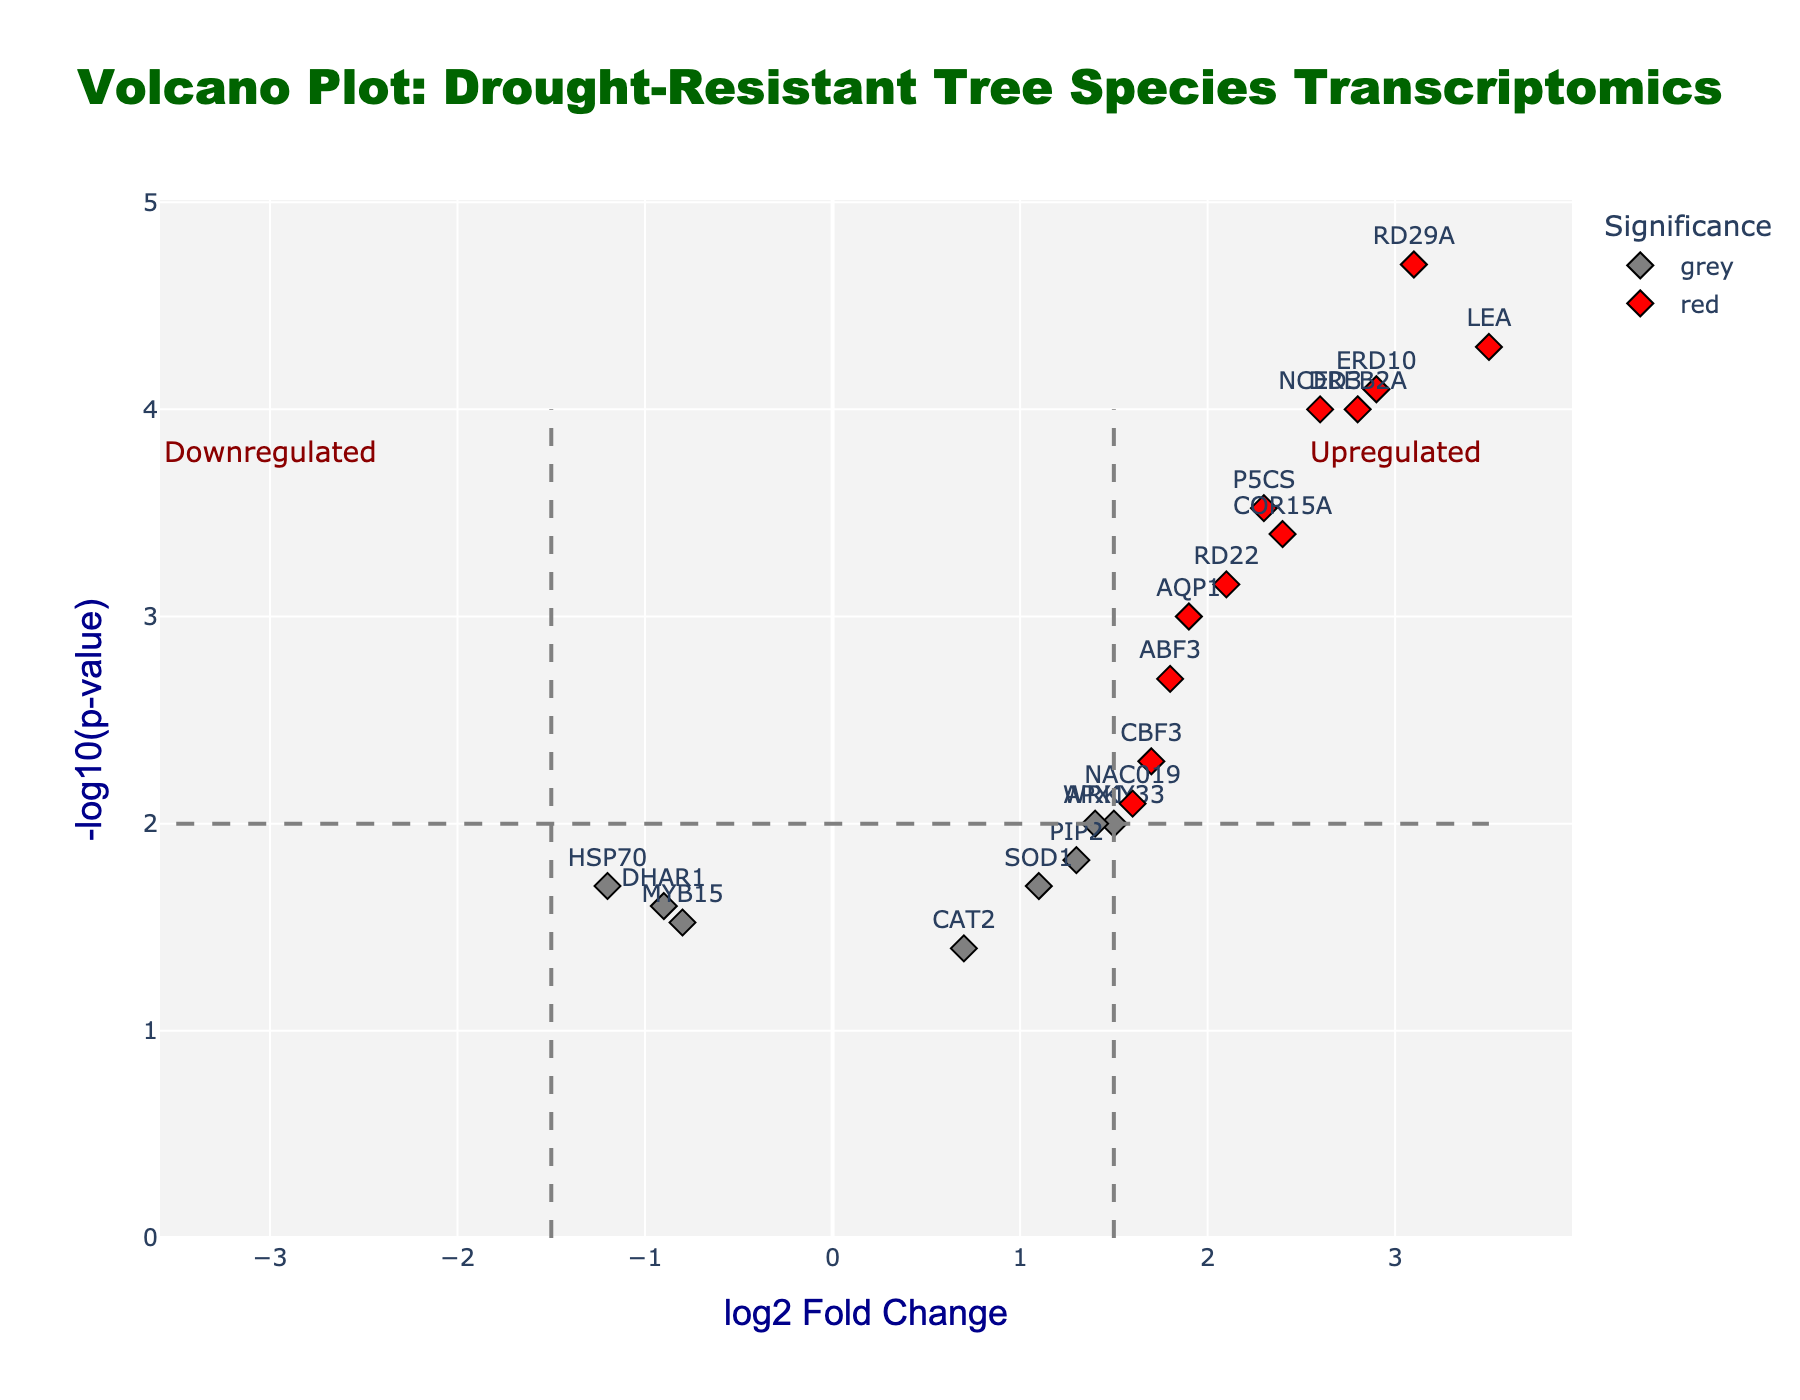What is the title of the figure? The title of the figure is displayed prominently at the top center. It indicates what the figure represents.
Answer: Volcano Plot: Drought-Resistant Tree Species Transcriptomics What is the x-axis label? The x-axis label is shown below the horizontal axis, indicating the variable plotted along this axis.
Answer: log2 Fold Change How many genes are marked in red? Genes marked in red meet the significance thresholds for both log2 fold change and p-value. Counting these red points gives the answer.
Answer: 9 Which gene has the highest log2 fold change? By looking at the x-axis (log2 fold change), identify the gene with the farthest right position.
Answer: LEA What is the p-value threshold line's -log10 value? The -log10 value of the p-value threshold can be seen where the horizontal dashed line intersects the y-axis.
Answer: 2 Which gene is positioned at approximately (-1.2, 1.7) on the plot? Locate the point with x-value close to -1.2 and y-value around 1.7, and identify the gene label associated with it.
Answer: HSP70 How does the significance of ABF3 compare to that of NAC019? Compare the vertical positions (-log10 p-value) of ABF3 and NAC019 to determine which is higher, indicating greater significance.
Answer: ABF3 is more significant than NAC019 Which genes are upregulated according to the plot? Genes in the right section of the plot (positive log2 fold change) that are also significant (red points) are considered upregulated.
Answer: DREB2A, LEA, AQP1, P5CS, RD29A, NCED3, ERD10, RD22, COR15A How many genes have a p-value less than 0.01 but a log2 fold change less than 1.5? Count the blue points on the plot, which indicate these genes' p-value and log2 fold change criteria.
Answer: 3 